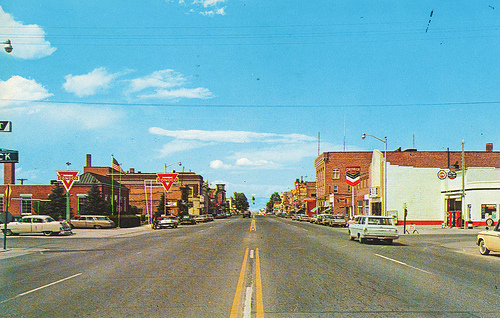<image>
Is the car behind the building? No. The car is not behind the building. From this viewpoint, the car appears to be positioned elsewhere in the scene. 